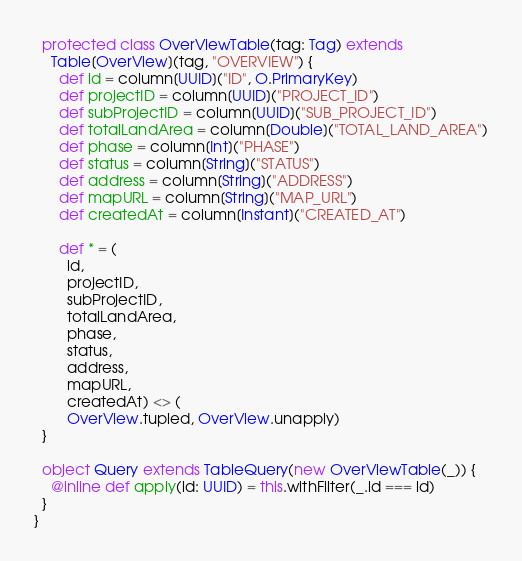Convert code to text. <code><loc_0><loc_0><loc_500><loc_500><_Scala_>  protected class OverViewTable(tag: Tag) extends 
    Table[OverView](tag, "OVERVIEW") {
      def id = column[UUID]("ID", O.PrimaryKey)
      def projectID = column[UUID]("PROJECT_ID")
      def subProjectID = column[UUID]("SUB_PROJECT_ID")
      def totalLandArea = column[Double]("TOTAL_LAND_AREA")
      def phase = column[Int]("PHASE")
      def status = column[String]("STATUS")
      def address = column[String]("ADDRESS")
      def mapURL = column[String]("MAP_URL")
      def createdAt = column[Instant]("CREATED_AT")

      def * = (
        id,
        projectID,
        subProjectID,
        totalLandArea,
        phase,
        status,
        address,
        mapURL,
        createdAt) <> (
        OverView.tupled, OverView.unapply)
  }

  object Query extends TableQuery(new OverViewTable(_)) {
    @inline def apply(id: UUID) = this.withFilter(_.id === id)
  }
}
</code> 